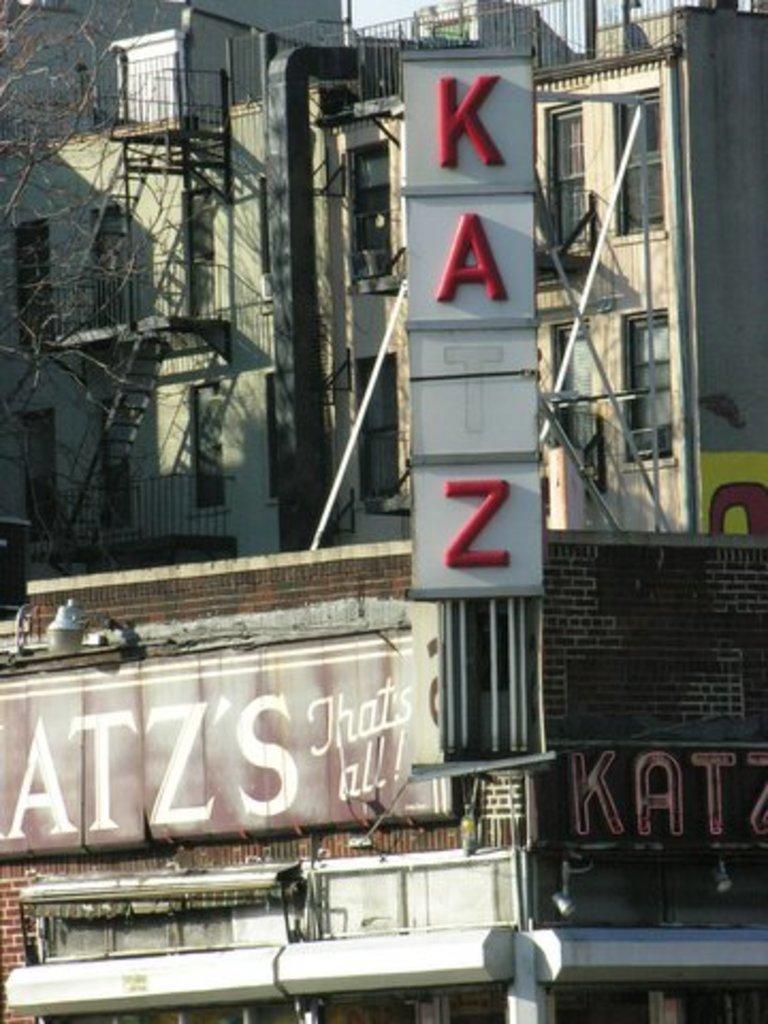Can you describe this image briefly? In this picture we can see few buildings, hoardings and metal rods, on the left side of the image we can see a tree. 